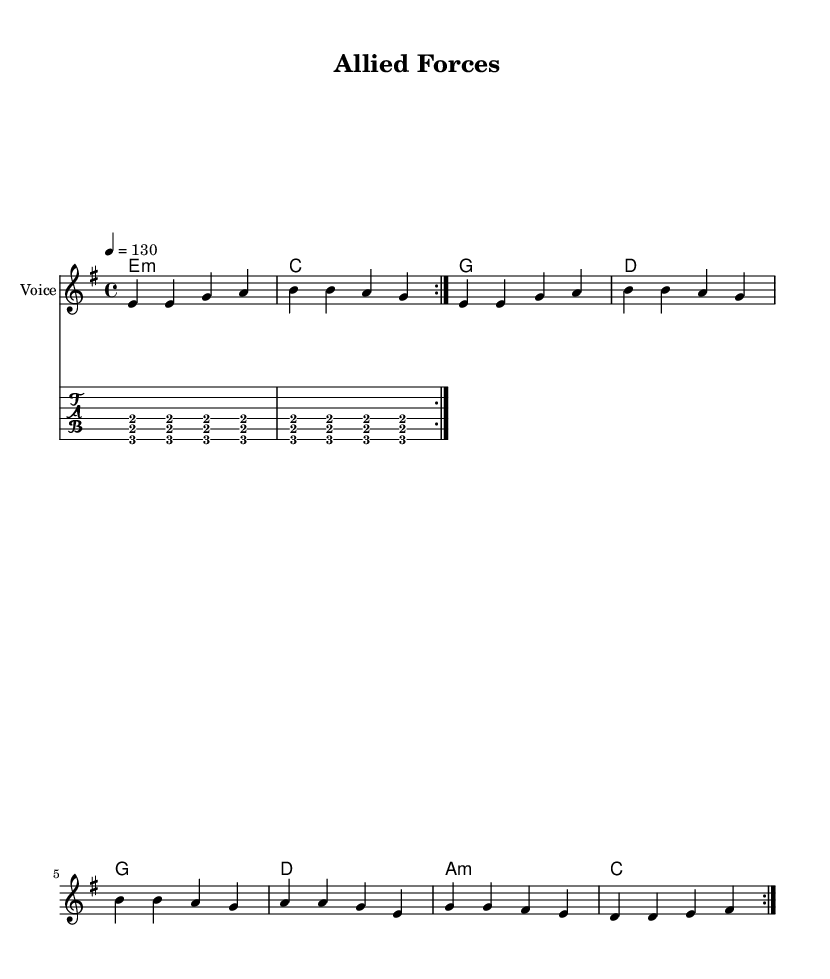What is the key signature of this music? The key signature indicates that there are no sharps or flats, which is characteristic of E minor.
Answer: E minor What is the time signature of the piece? The time signature is noted at the beginning of the score, showing a 4 over 4, indicating four beats per measure.
Answer: 4/4 What is the tempo marking for this piece? The tempo is indicated by the notation "4 = 130", which means there are 130 beats per minute for the quarter note.
Answer: 130 How many times is the melody repeated in the score? The repeat instruction "volta 2" indicates that the melody section is to be played twice.
Answer: 2 What is the introductory lyrical theme of the song? The lyrics start with a line describing chaos in the world and unity among allies, providing the thematic context of global security.
Answer: In a world of chaos What type of chord is primarily used in the harmonies of this piece? The first chord in the sequence is marked as "e1:m," which stands for E minor, and this set of chords features minor chords prominently.
Answer: E minor What is the main message conveyed in the chorus lyrics? The chorus emphasizes strength and unity among forces for global security, anchoring the overall theme of defense and collaboration.
Answer: Global security 